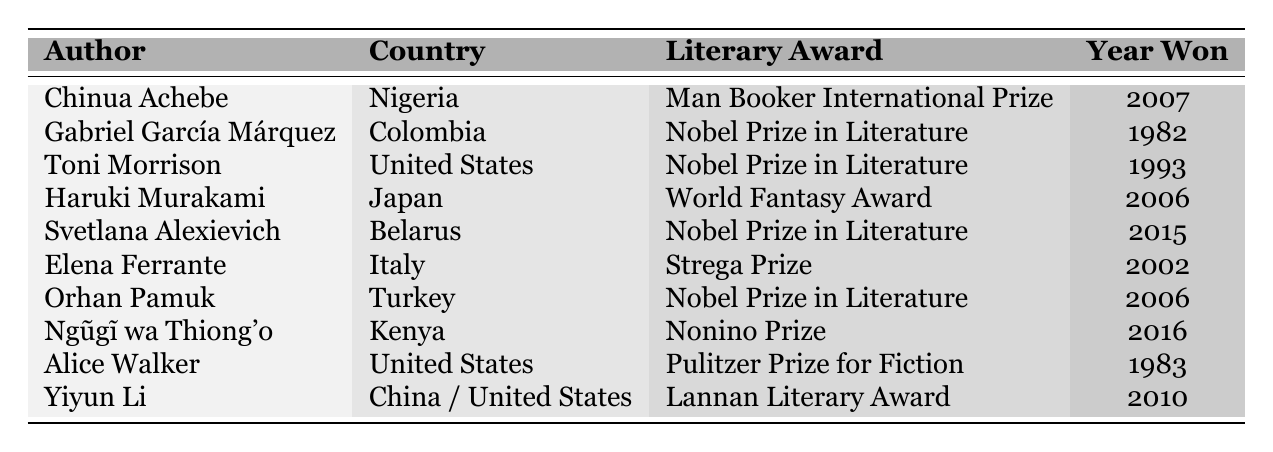What literary award did Chinua Achebe win? The table lists that Chinua Achebe won the Man Booker International Prize in 2007.
Answer: Man Booker International Prize Which author from Kenya won a literary award? The table shows that Ngũgĩ wa Thiong'o from Kenya won the Nonino Prize in 2016.
Answer: Ngũgĩ wa Thiong'o How many authors won the Nobel Prize in Literature? The table indicates that four authors (Gabriel García Márquez, Toni Morrison, Svetlana Alexievich, and Orhan Pamuk) won the Nobel Prize in Literature.
Answer: 4 In what year did Haruki Murakami win his award? According to the table, Haruki Murakami won the World Fantasy Award in 2006.
Answer: 2006 Did any authors from the United States win the Nobel Prize in Literature? The table confirms that Toni Morrison won the Nobel Prize in Literature, so the answer is yes.
Answer: Yes Which literary award was won by an author from Belarus? The table states that Svetlana Alexievich from Belarus won the Nobel Prize in Literature in 2015.
Answer: Nobel Prize in Literature What is the earliest year an author received a literary award in this table? By examining the years listed, the earliest is 1982 when Gabriel García Márquez won the Nobel Prize in Literature.
Answer: 1982 How many authors in the table have won a prize that includes the word "Prize" in its name? The table reveals that six authors won awards containing "Prize" (Man Booker International Prize, Nobel Prize in Literature, Pulitzer Prize for Fiction, Nonino Prize).
Answer: 6 Which author won a literary award in 2010? Yiyun Li is shown in the table as having won the Lannan Literary Award in 2010.
Answer: Yiyun Li Is there an author who received an award specifically for fiction? Yes, Alice Walker won the Pulitzer Prize for Fiction, as indicated in the table.
Answer: Yes What distinguishes the awards won by authors from United States and Kenya in terms of their names? Authors from the United States won "Nobel Prize in Literature" and "Pulitzer Prize for Fiction," while the Kenyan author won the "Nonino Prize," which has a distinct name compared to the other two.
Answer: Different award names Which country has the most Nobel Prize in Literature winners in this table? The table shows that the United States and Colombia have a Nobel Prize winner each, but four awards belong to authors from other countries, making the total count for the U.S. at three, making it the country with the most Nobel Prize in Literature.
Answer: United States What is the average year of the awards won by the authors? To find the average, sum the years (1982 + 1983 + 2002 + 2006 + 2006 + 2007 + 2010 + 2015 + 1993 + 2016) = 2004, and divide by the number of authors (10), giving an average year of 2004.
Answer: 2004 